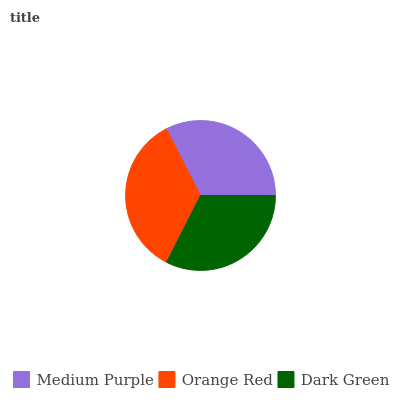Is Dark Green the minimum?
Answer yes or no. Yes. Is Orange Red the maximum?
Answer yes or no. Yes. Is Orange Red the minimum?
Answer yes or no. No. Is Dark Green the maximum?
Answer yes or no. No. Is Orange Red greater than Dark Green?
Answer yes or no. Yes. Is Dark Green less than Orange Red?
Answer yes or no. Yes. Is Dark Green greater than Orange Red?
Answer yes or no. No. Is Orange Red less than Dark Green?
Answer yes or no. No. Is Medium Purple the high median?
Answer yes or no. Yes. Is Medium Purple the low median?
Answer yes or no. Yes. Is Dark Green the high median?
Answer yes or no. No. Is Dark Green the low median?
Answer yes or no. No. 